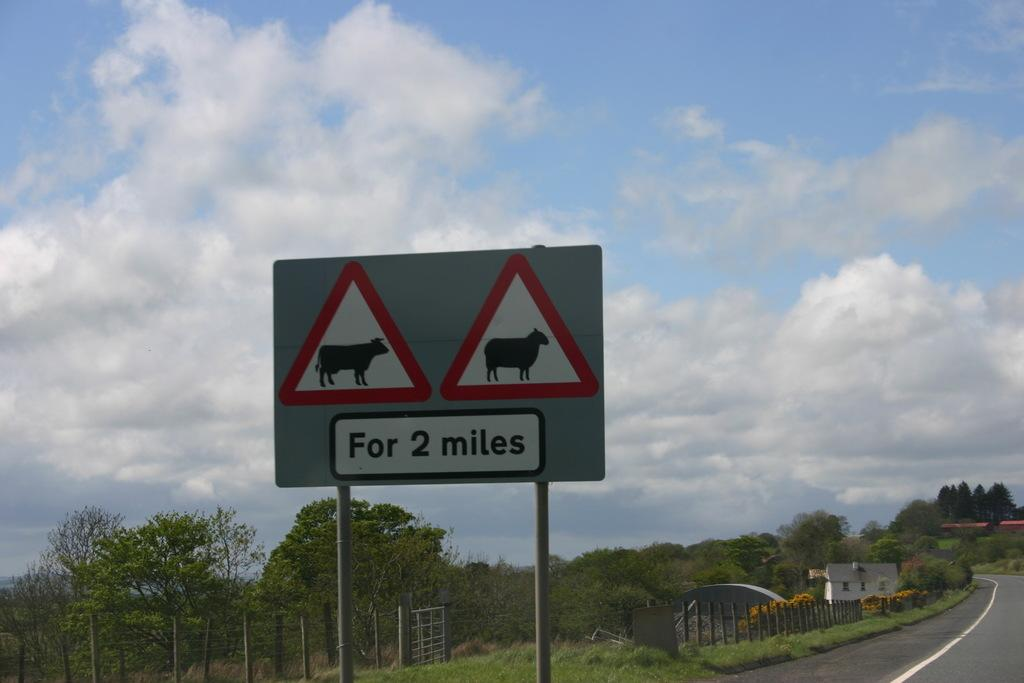<image>
Provide a brief description of the given image. A sign on the side of the road informs of cows and sheep for 2 miles. 